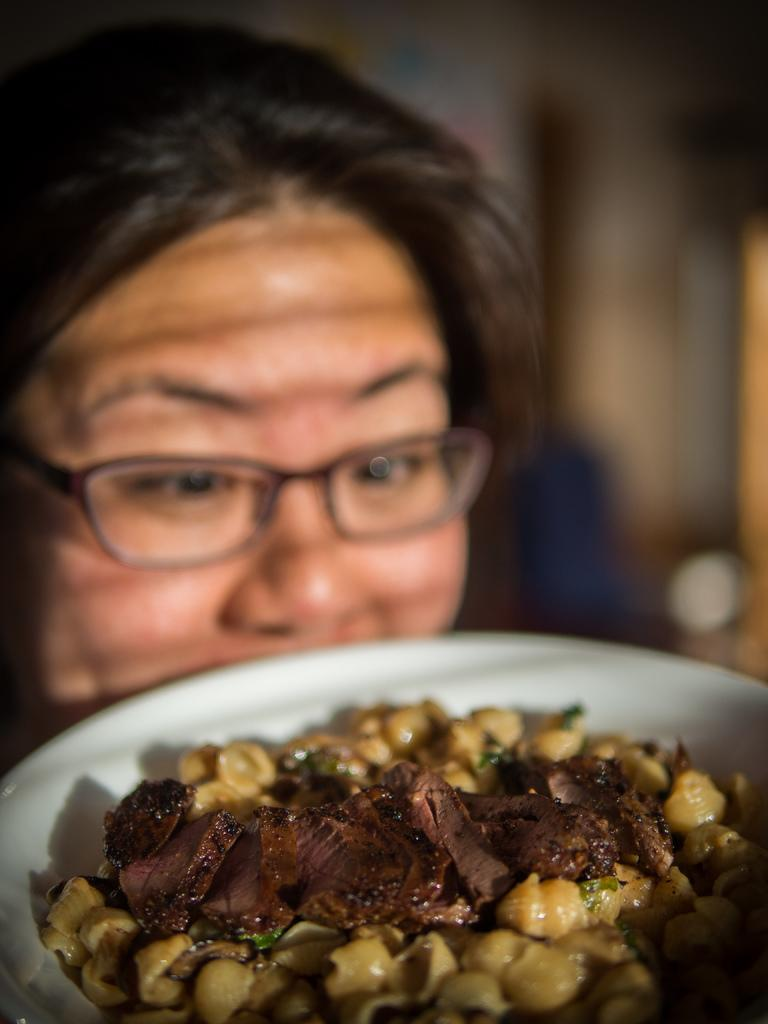What can be seen in the image? There is a person in the image. Can you describe the person's appearance? The person is wearing spectacles. What is in front of the person? There is food in a white bowl in front of the person. How would you describe the background of the image? The background of the image is blurred. Can you tell me how many bears are visible in the image? There are no bears present in the image. What type of voice can be heard coming from the person in the image? The image is a still picture, so there is no sound or voice present. 